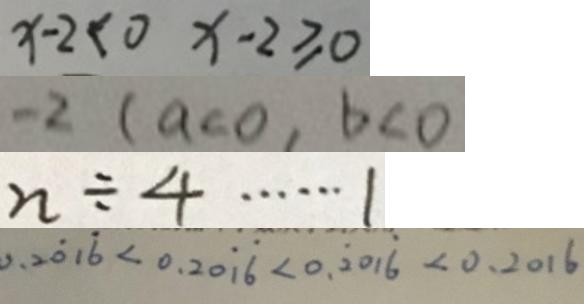<formula> <loc_0><loc_0><loc_500><loc_500>x - 2 < 0 x - 2 \geqslant 0 
 - 2 ( a < 0 , b < 0 
 n \div 4 \cdots 1 
 0 . 2 \dot { 0 } 1 \dot { 6 } < 0 . 2 0 \dot { 1 } \dot { 6 } < 0 . \dot { 2 } 0 1 \dot { 6 } < 0 . 2 0 1 6</formula> 